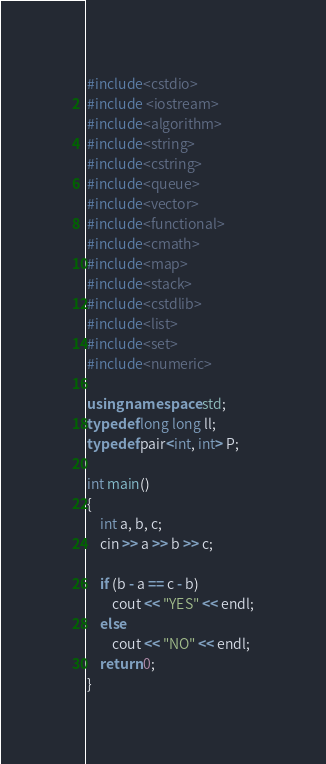Convert code to text. <code><loc_0><loc_0><loc_500><loc_500><_C++_>#include<cstdio>
#include <iostream>
#include<algorithm>
#include<string>
#include<cstring>
#include<queue>
#include<vector>
#include<functional>
#include<cmath>
#include<map>
#include<stack>
#include<cstdlib>
#include<list>
#include<set>
#include<numeric>

using namespace std;
typedef long long ll;
typedef pair<int, int> P;

int main()
{
	int a, b, c;
	cin >> a >> b >> c;

	if (b - a == c - b)
		cout << "YES" << endl;
	else
		cout << "NO" << endl;
	return 0;
}</code> 